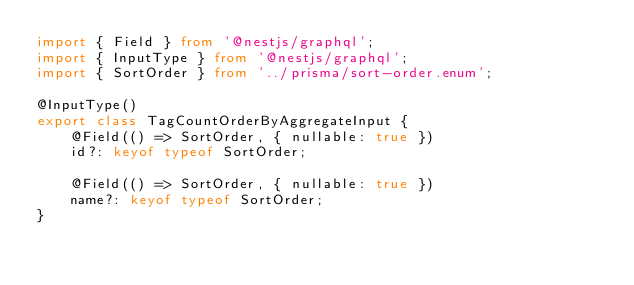Convert code to text. <code><loc_0><loc_0><loc_500><loc_500><_TypeScript_>import { Field } from '@nestjs/graphql';
import { InputType } from '@nestjs/graphql';
import { SortOrder } from '../prisma/sort-order.enum';

@InputType()
export class TagCountOrderByAggregateInput {
    @Field(() => SortOrder, { nullable: true })
    id?: keyof typeof SortOrder;

    @Field(() => SortOrder, { nullable: true })
    name?: keyof typeof SortOrder;
}
</code> 